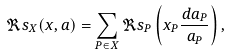<formula> <loc_0><loc_0><loc_500><loc_500>\Re s _ { X } ( x , a ) = \sum _ { P \in X } \Re s _ { P } \left ( x _ { P } \frac { d a _ { P } } { a _ { P } } \right ) ,</formula> 